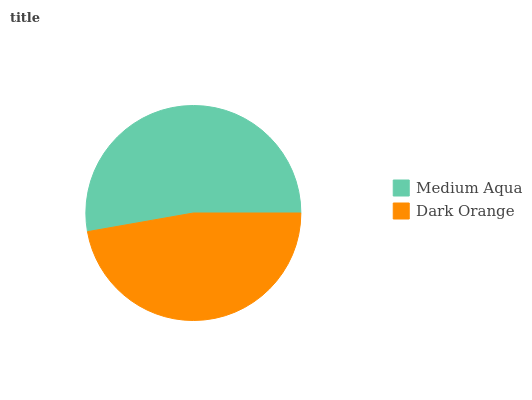Is Dark Orange the minimum?
Answer yes or no. Yes. Is Medium Aqua the maximum?
Answer yes or no. Yes. Is Dark Orange the maximum?
Answer yes or no. No. Is Medium Aqua greater than Dark Orange?
Answer yes or no. Yes. Is Dark Orange less than Medium Aqua?
Answer yes or no. Yes. Is Dark Orange greater than Medium Aqua?
Answer yes or no. No. Is Medium Aqua less than Dark Orange?
Answer yes or no. No. Is Medium Aqua the high median?
Answer yes or no. Yes. Is Dark Orange the low median?
Answer yes or no. Yes. Is Dark Orange the high median?
Answer yes or no. No. Is Medium Aqua the low median?
Answer yes or no. No. 